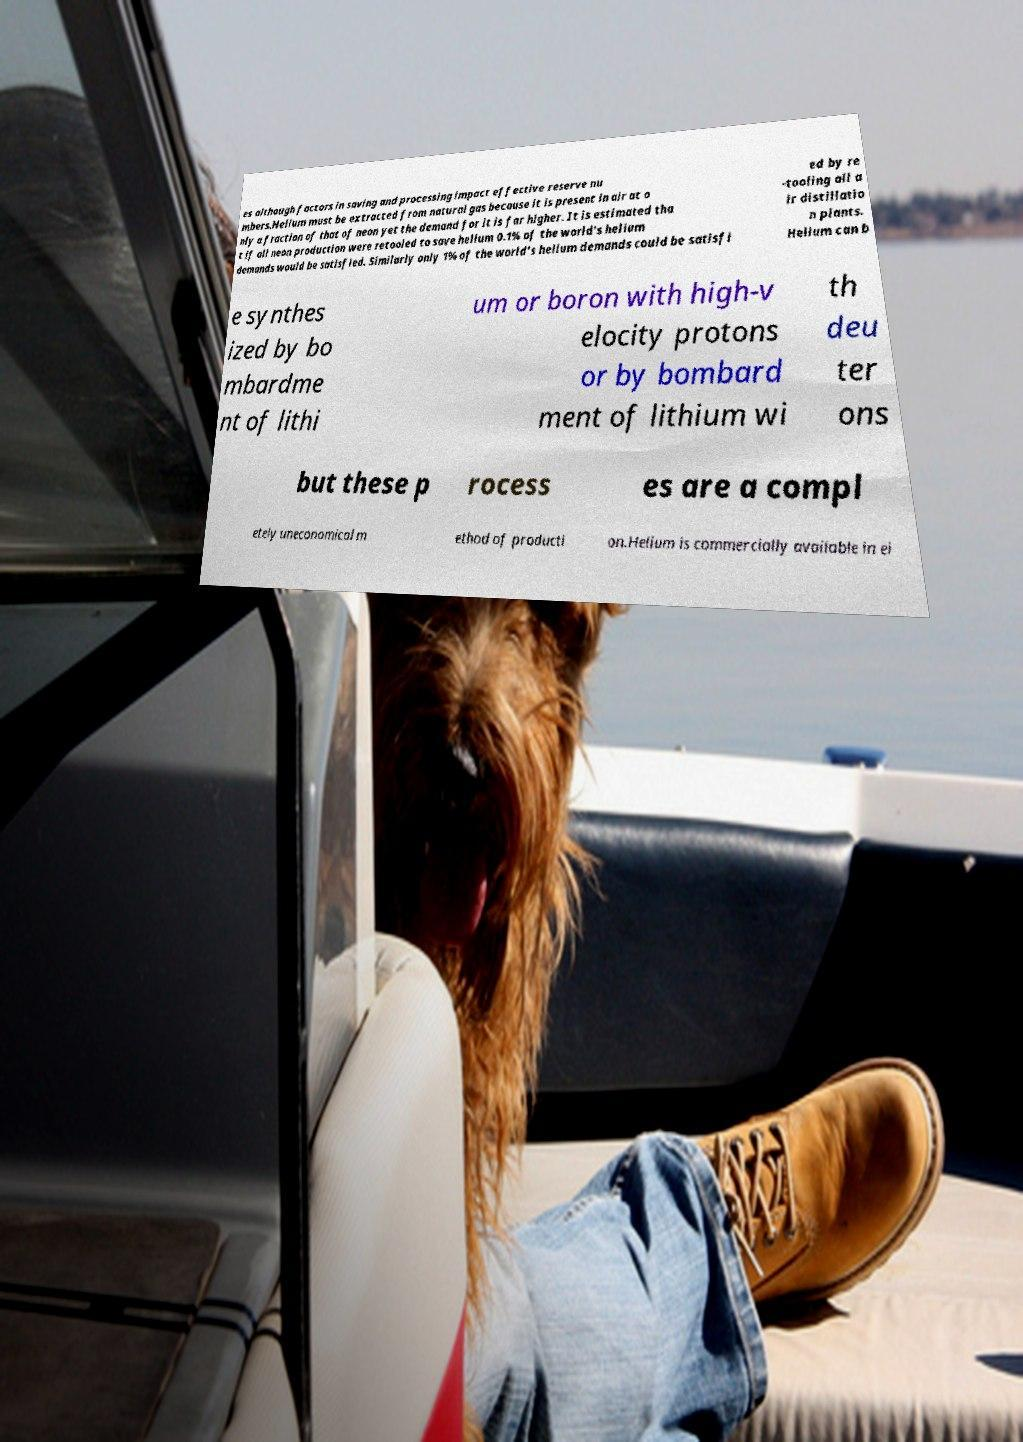Can you accurately transcribe the text from the provided image for me? es although factors in saving and processing impact effective reserve nu mbers.Helium must be extracted from natural gas because it is present in air at o nly a fraction of that of neon yet the demand for it is far higher. It is estimated tha t if all neon production were retooled to save helium 0.1% of the world's helium demands would be satisfied. Similarly only 1% of the world's helium demands could be satisfi ed by re -tooling all a ir distillatio n plants. Helium can b e synthes ized by bo mbardme nt of lithi um or boron with high-v elocity protons or by bombard ment of lithium wi th deu ter ons but these p rocess es are a compl etely uneconomical m ethod of producti on.Helium is commercially available in ei 